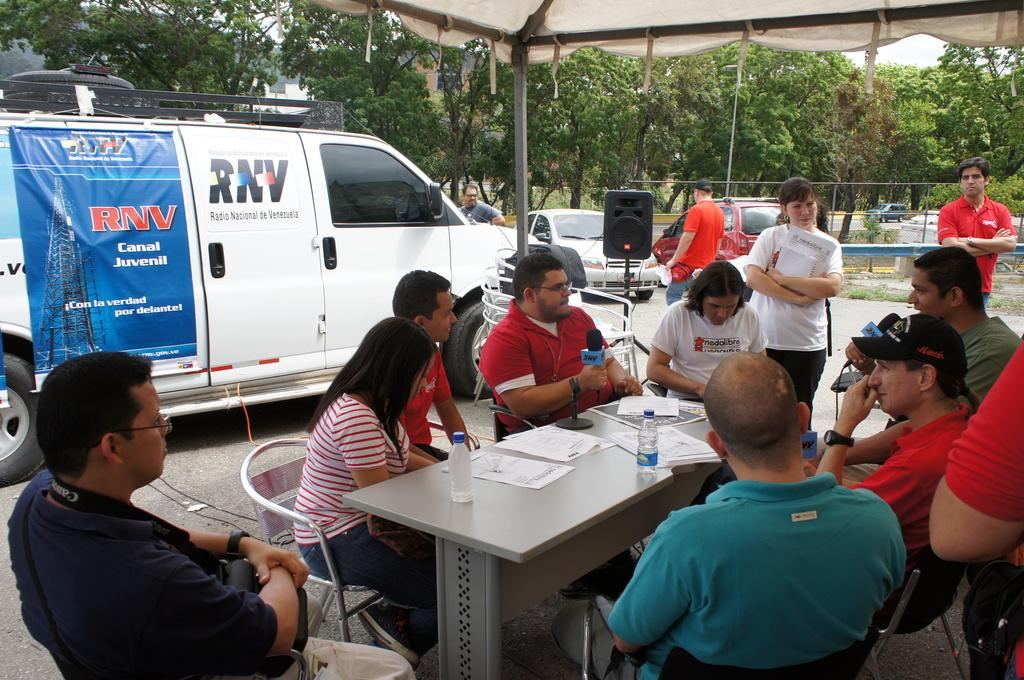How many people are in the image? There is a group of people in the image. What are the people doing in the image? The people are sitting on chairs. Where are the chairs located in relation to the table? The chairs are in front of a table. What can be found on the table? There are objects on the table. What is visible on the road in the image? There is a vehicle visible on the road. Can you see any sea creatures swimming near the people in the image? There is no sea or sea creatures present in the image. 